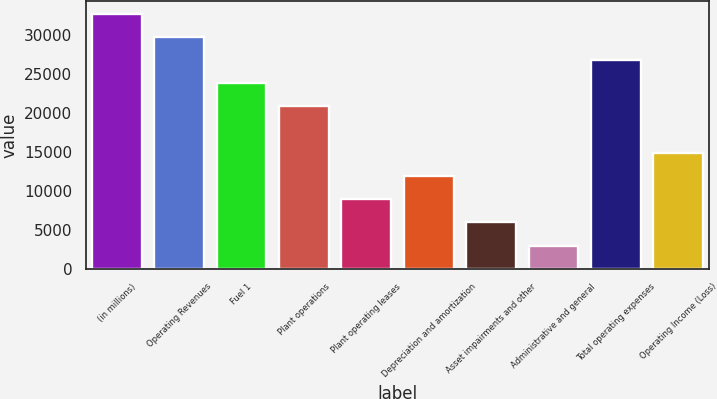Convert chart to OTSL. <chart><loc_0><loc_0><loc_500><loc_500><bar_chart><fcel>(in millions)<fcel>Operating Revenues<fcel>Fuel 1<fcel>Plant operations<fcel>Plant operating leases<fcel>Depreciation and amortization<fcel>Asset impairments and other<fcel>Administrative and general<fcel>Total operating expenses<fcel>Operating Income (Loss)<nl><fcel>32777.3<fcel>29798<fcel>23839.4<fcel>20860.1<fcel>8942.9<fcel>11922.2<fcel>5963.6<fcel>2984.3<fcel>26818.7<fcel>14901.5<nl></chart> 